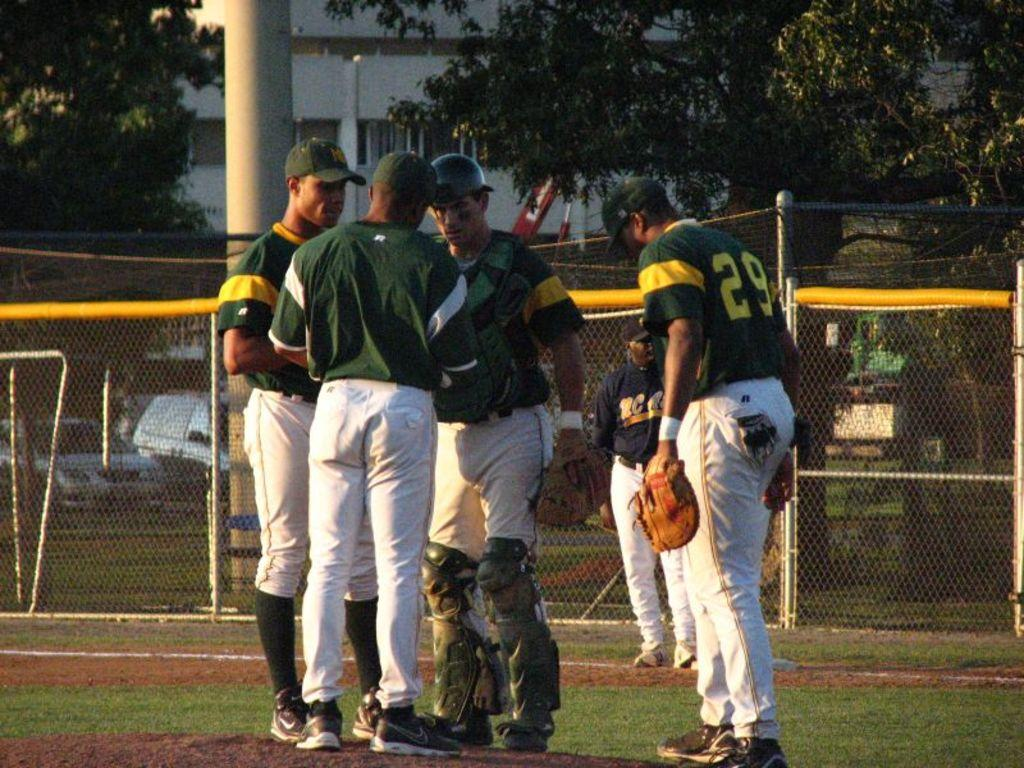Provide a one-sentence caption for the provided image. Baseball players wearing green and yellow jerseys with white pants huddle around talking among them player 29. 